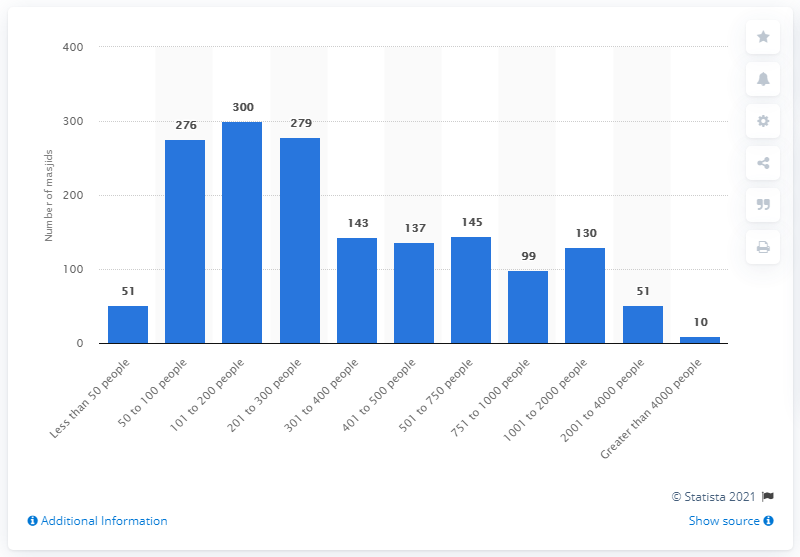List a handful of essential elements in this visual. In 2017, there were approximately 300 mosques in the United Kingdom. In 2019, approximately 279 masjids (Islamic places of worship) had a capacity between 201 and 300 people. 